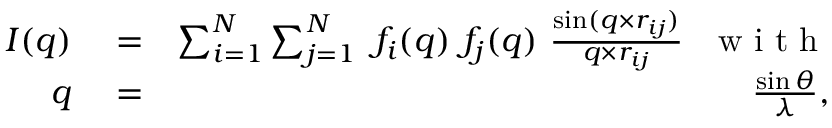<formula> <loc_0><loc_0><loc_500><loc_500>\begin{array} { r l r } { I ( q ) } & = } & { \sum _ { i = 1 } ^ { N } \sum _ { j = 1 } ^ { N } \ f _ { i } ( q ) \ f _ { j } ( q ) \ \frac { \sin ( q \times r _ { i j } ) } { q \times r _ { i j } } \ \ w i t h } \\ { q } & = } & { \frac { \sin \theta } { \lambda } , } \end{array}</formula> 